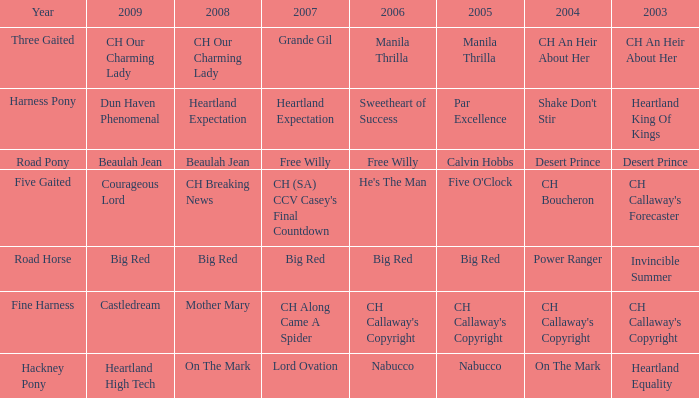What is the 2008 for the 2009 ch our charming lady? CH Our Charming Lady. 